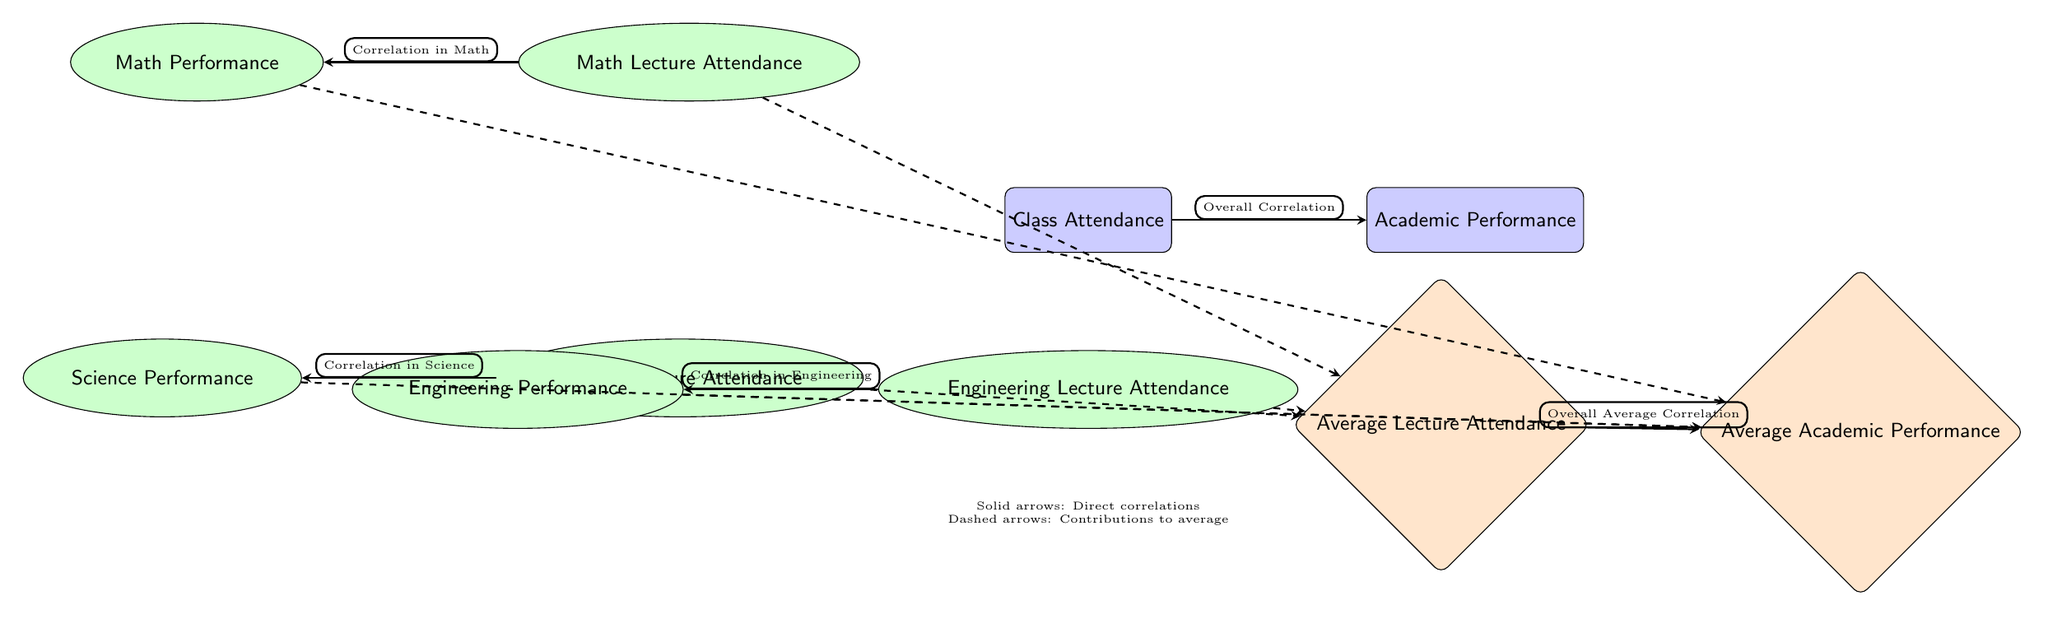What is represented by the node labeled "Class Attendance"? The node "Class Attendance" is a key variable in the diagram representing how much students attend classes overall. It serves as a central factor connecting to academic performance.
Answer: Class Attendance How many subject nodes are present in the diagram? The diagram contains three subject nodes specifically related to different academic areas: Math, Science, and Engineering. Each subject has its own attendance and performance indicators.
Answer: Three What is the relationship indicated between "Math Lecture Attendance" and "Math Performance"? The diagram indicates a direct correlation between "Math Lecture Attendance" and "Math Performance" through a solid arrow, suggesting that higher attendance in math lectures is linked to better performance in math.
Answer: Correlation in Math What type of arrow indicates contributions to average performance? The diagram distinguishes the type of relationships with solid and dashed arrows; dashed arrows symbolize contributions to average performance rather than direct correlations.
Answer: Dashed What is the average node for academic performance labeled as? The node that represents the average of academic performance within the diagram is labeled "Average Academic Performance." It aggregates the performance across the subject areas.
Answer: Average Academic Performance How does "Average Lecture Attendance" relate to "Average Academic Performance"? The arrow from "Average Lecture Attendance" to "Average Academic Performance" indicates that there is an overall average correlation; this shows that average attendance contributes towards the average performance across subjects.
Answer: Overall Average Correlation Which subject area shows the relationship between attendance and performance at the lowest node position? In terms of vertical placement, the lowest subject area-related nodes in the diagram are "Engineering Lecture Attendance" and "Engineering Performance," reflecting how they are positioned in the layout.
Answer: Engineering What type of relationship does "Science Lecture Attendance" have with its corresponding performance node? "Science Lecture Attendance" is linked to "Science Performance" through a solid arrow, meaning it demonstrates a direct correlation showing that attendance affects performance in science directly.
Answer: Correlation in Science Which node acts as a central link between all subject attendance and their performances? The "Class Attendance" node serves as the central hub in the diagram, indicating its role in the correlation analysis of academic performance across all subjects.
Answer: Class Attendance 